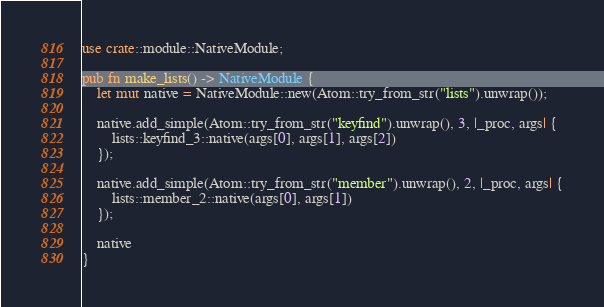<code> <loc_0><loc_0><loc_500><loc_500><_Rust_>
use crate::module::NativeModule;

pub fn make_lists() -> NativeModule {
    let mut native = NativeModule::new(Atom::try_from_str("lists").unwrap());

    native.add_simple(Atom::try_from_str("keyfind").unwrap(), 3, |_proc, args| {
        lists::keyfind_3::native(args[0], args[1], args[2])
    });

    native.add_simple(Atom::try_from_str("member").unwrap(), 2, |_proc, args| {
        lists::member_2::native(args[0], args[1])
    });

    native
}
</code> 